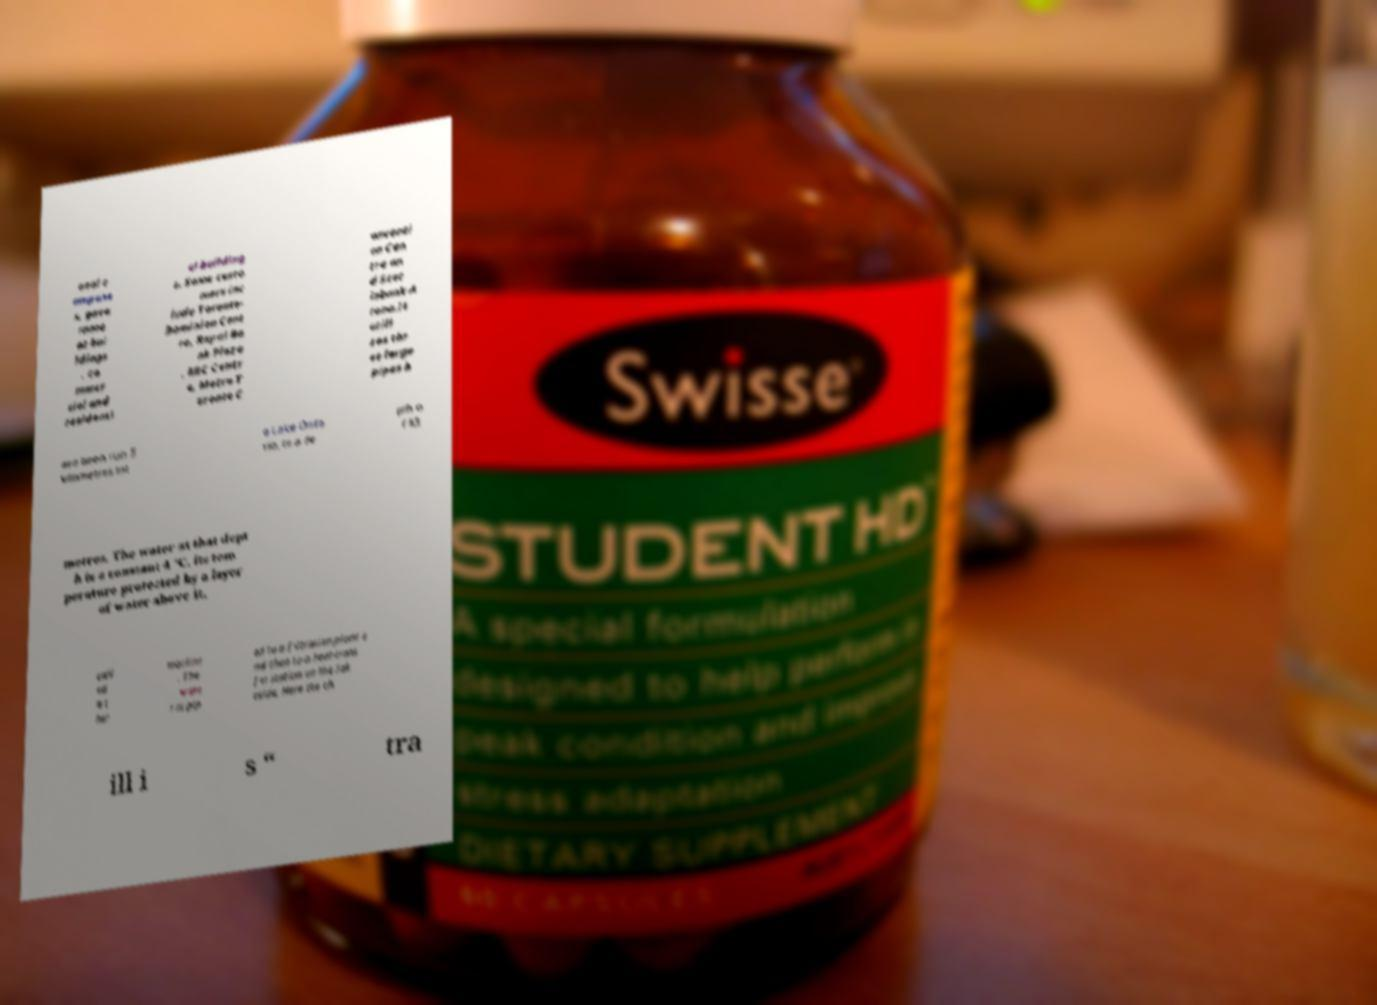For documentation purposes, I need the text within this image transcribed. Could you provide that? onal c ampuse s, gove rnme nt bui ldings , co mmer cial and residenti al building s. Some custo mers inc lude Toronto- Dominion Cent re, Royal Ba nk Plaza , RBC Centr e, Metro T oronto C onventi on Cen tre an d Scot iabank A rena.It utili zes thr ee large pipes h ave been run 5 kilometres int o Lake Onta rio, to a de pth o f 83 metres. The water at that dept h is a constant 4 °C, its tem perature protected by a layer of water above it, call ed a t her mocline . The wate r is pip ed to a filtration plant a nd then to a heat-trans fer station on the lak eside. Here the ch ill i s “ tra 